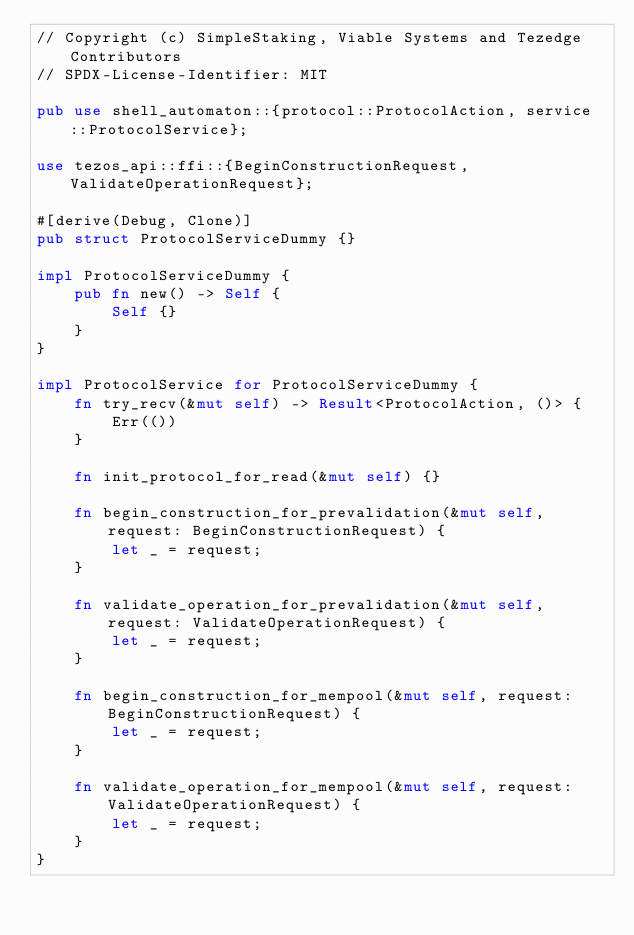<code> <loc_0><loc_0><loc_500><loc_500><_Rust_>// Copyright (c) SimpleStaking, Viable Systems and Tezedge Contributors
// SPDX-License-Identifier: MIT

pub use shell_automaton::{protocol::ProtocolAction, service::ProtocolService};

use tezos_api::ffi::{BeginConstructionRequest, ValidateOperationRequest};

#[derive(Debug, Clone)]
pub struct ProtocolServiceDummy {}

impl ProtocolServiceDummy {
    pub fn new() -> Self {
        Self {}
    }
}

impl ProtocolService for ProtocolServiceDummy {
    fn try_recv(&mut self) -> Result<ProtocolAction, ()> {
        Err(())
    }

    fn init_protocol_for_read(&mut self) {}

    fn begin_construction_for_prevalidation(&mut self, request: BeginConstructionRequest) {
        let _ = request;
    }

    fn validate_operation_for_prevalidation(&mut self, request: ValidateOperationRequest) {
        let _ = request;
    }

    fn begin_construction_for_mempool(&mut self, request: BeginConstructionRequest) {
        let _ = request;
    }

    fn validate_operation_for_mempool(&mut self, request: ValidateOperationRequest) {
        let _ = request;
    }
}
</code> 